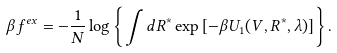<formula> <loc_0><loc_0><loc_500><loc_500>\beta f ^ { e x } = - \frac { 1 } { N } \log \left \{ \int d { R } ^ { * } \exp \left [ - \beta U _ { 1 } ( V , { R } ^ { * } , \lambda ) \right ] \right \} .</formula> 